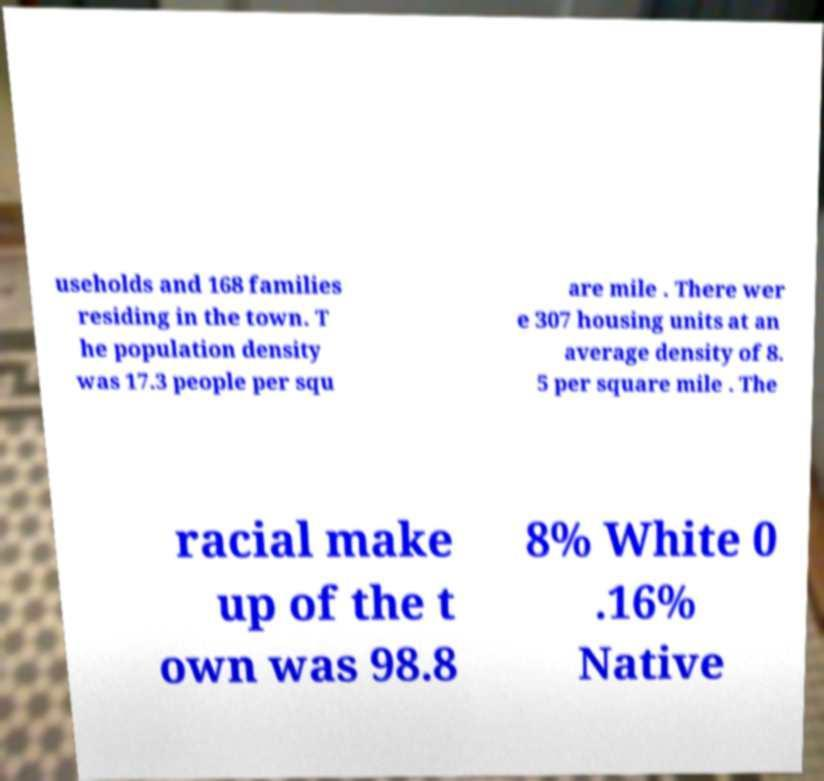Could you extract and type out the text from this image? useholds and 168 families residing in the town. T he population density was 17.3 people per squ are mile . There wer e 307 housing units at an average density of 8. 5 per square mile . The racial make up of the t own was 98.8 8% White 0 .16% Native 